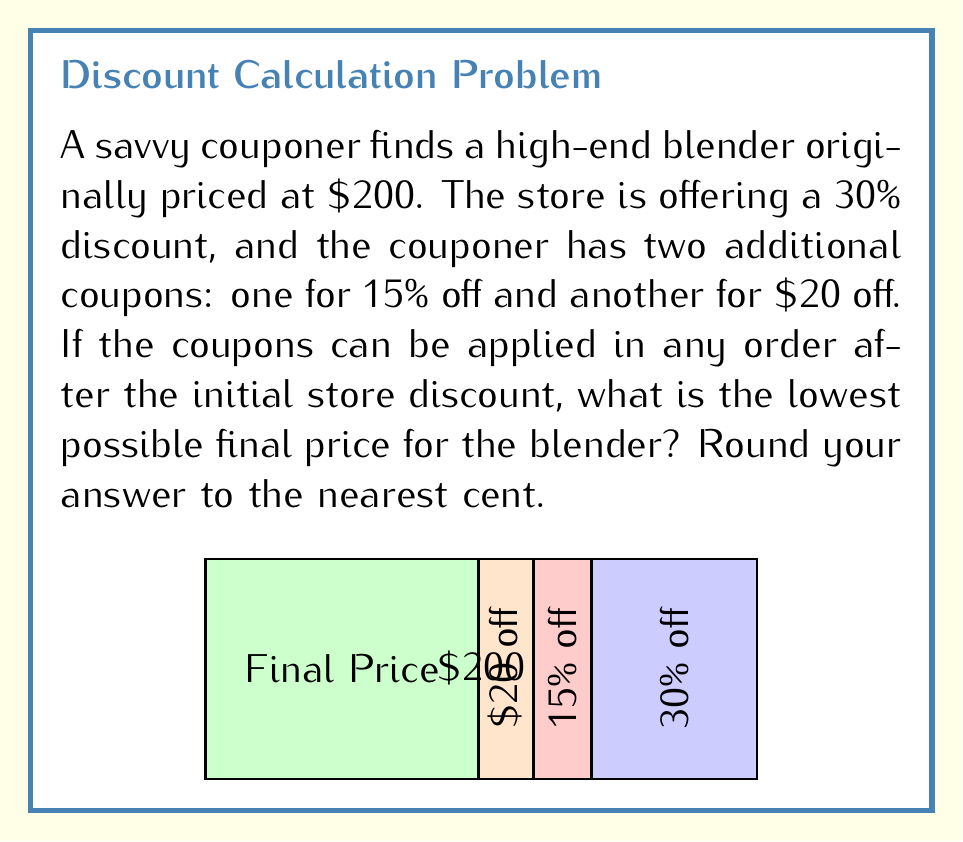Teach me how to tackle this problem. Let's approach this step-by-step:

1) First, apply the store's 30% discount:
   $$200 - (200 \times 0.30) = 200 - 60 = 140$$

2) Now we have two options for the next step: apply the 15% off coupon or the $20 off coupon. To get the lowest price, we should apply the percentage discount before the fixed amount discount.

3) Apply the 15% off coupon:
   $$140 - (140 \times 0.15) = 140 - 21 = 119$$

4) Finally, apply the $20 off coupon:
   $$119 - 20 = 99$$

5) Therefore, the lowest possible price is $99.00.

Note: If we had applied the $20 off coupon before the 15% off coupon, the final price would have been:
   $$140 - 20 = 120$$
   $$120 - (120 \times 0.15) = 120 - 18 = 102$$

This confirms that applying the percentage discount before the fixed amount discount results in a lower final price.
Answer: $99.00 